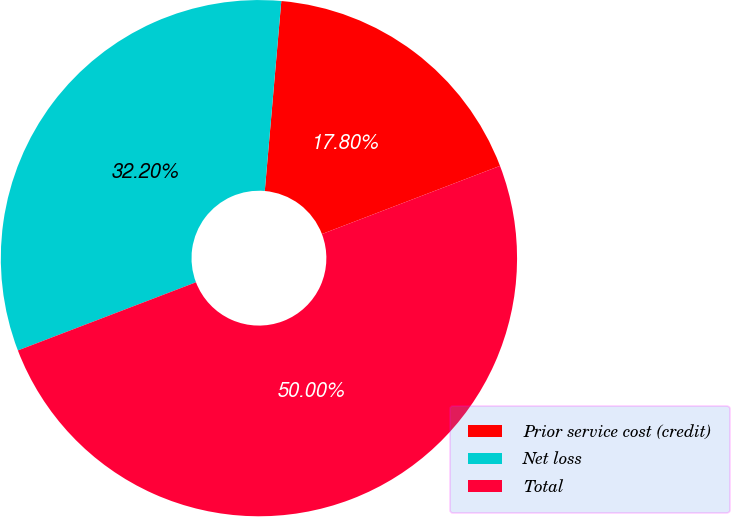Convert chart to OTSL. <chart><loc_0><loc_0><loc_500><loc_500><pie_chart><fcel>Prior service cost (credit)<fcel>Net loss<fcel>Total<nl><fcel>17.8%<fcel>32.2%<fcel>50.0%<nl></chart> 